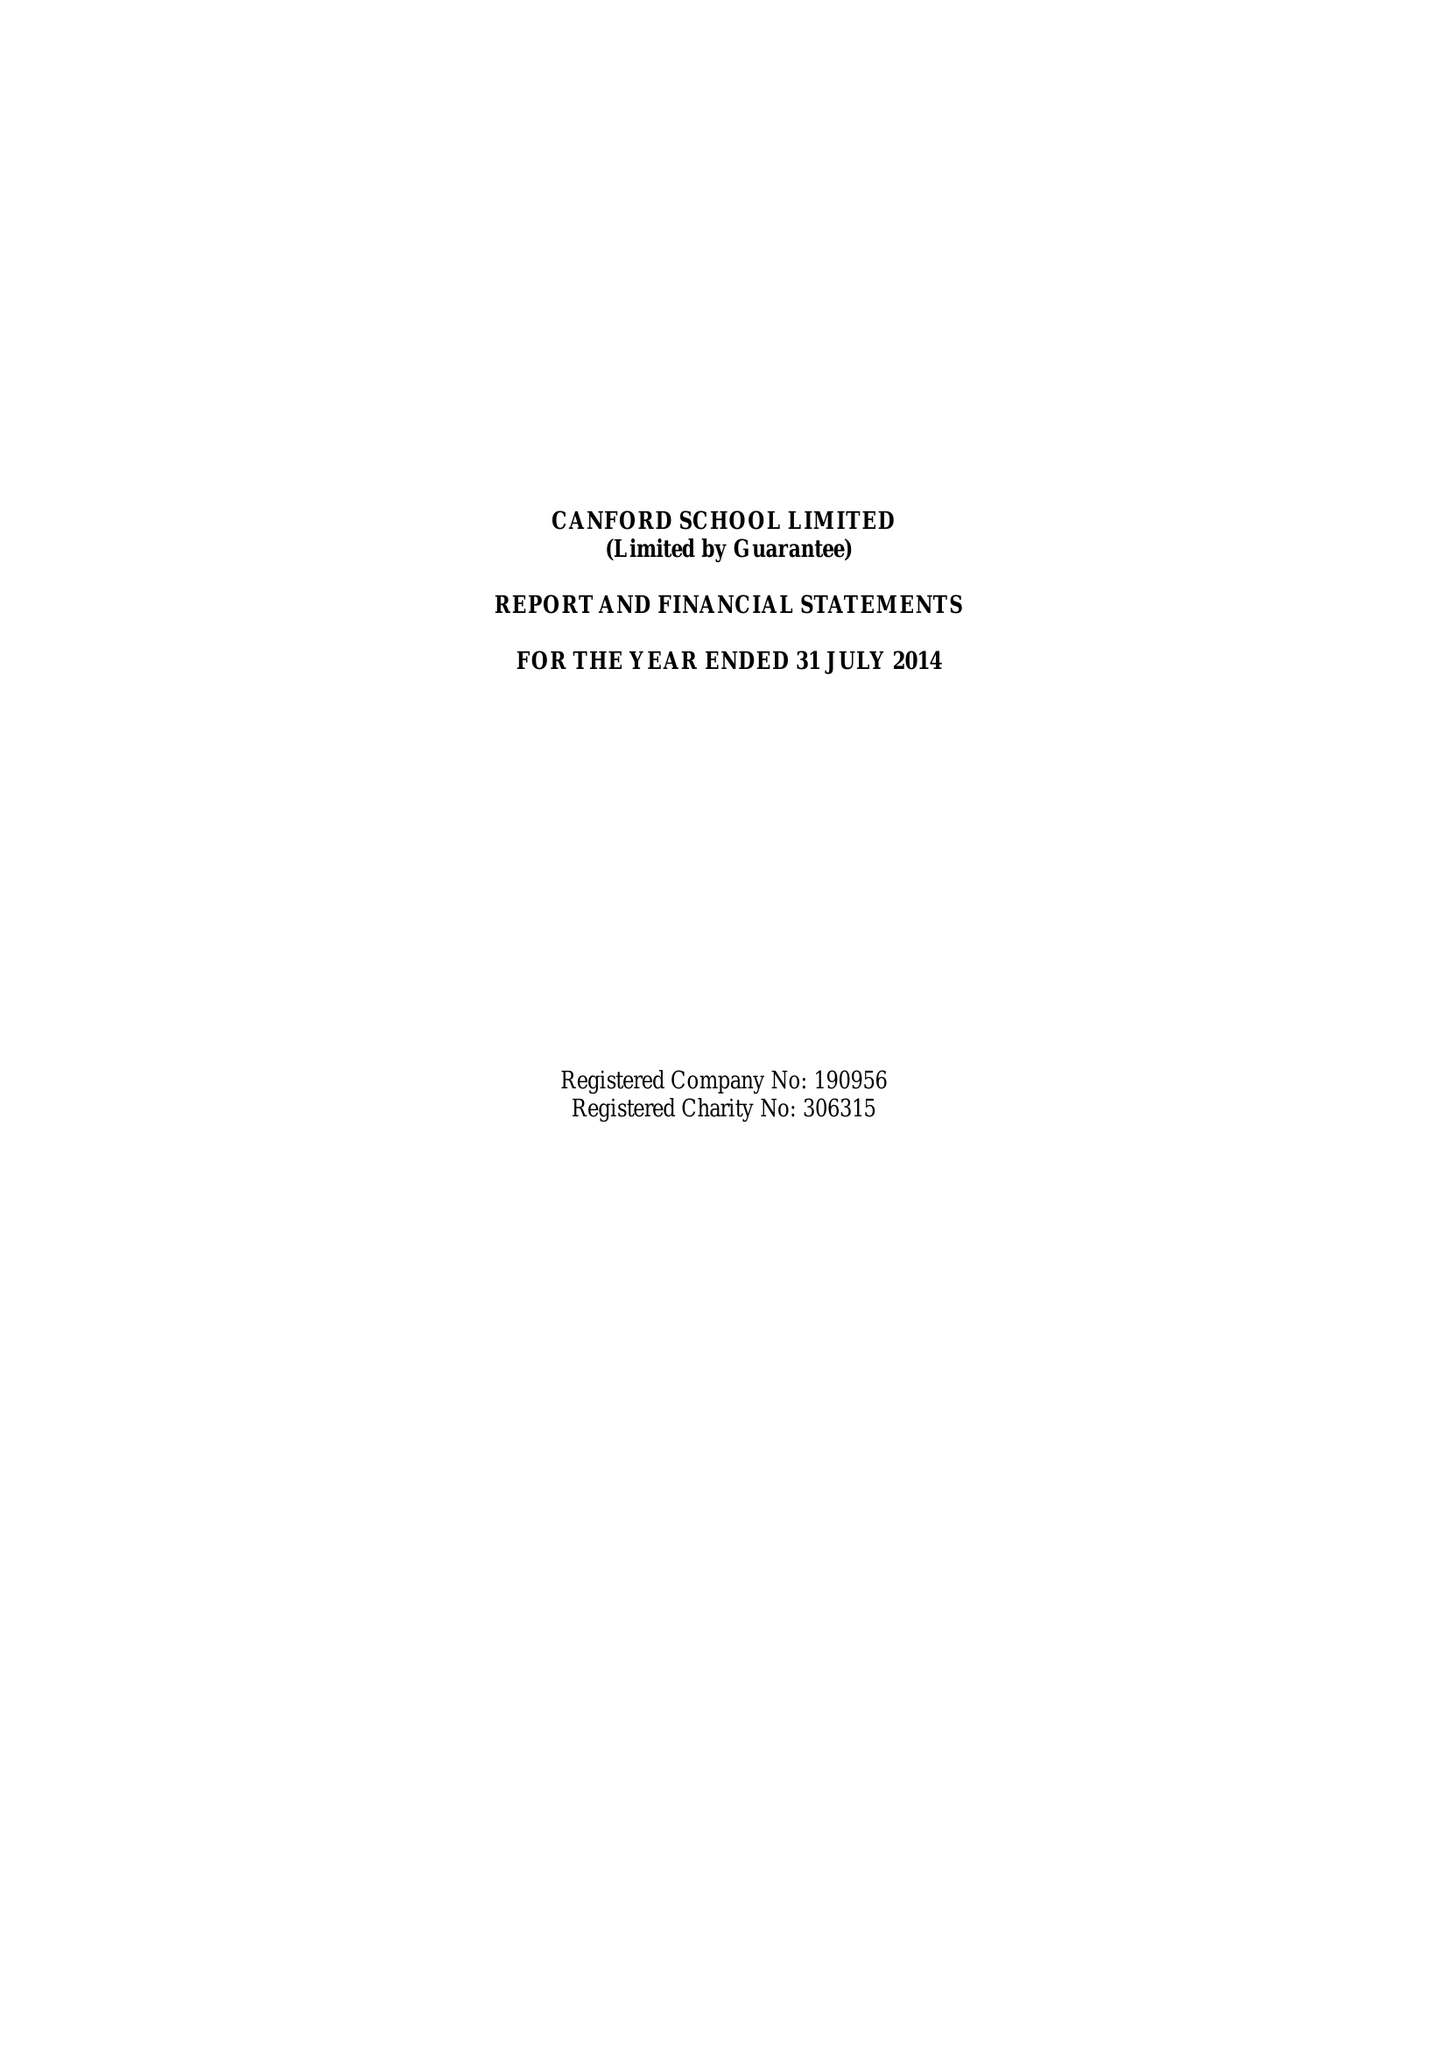What is the value for the charity_number?
Answer the question using a single word or phrase. 306315 